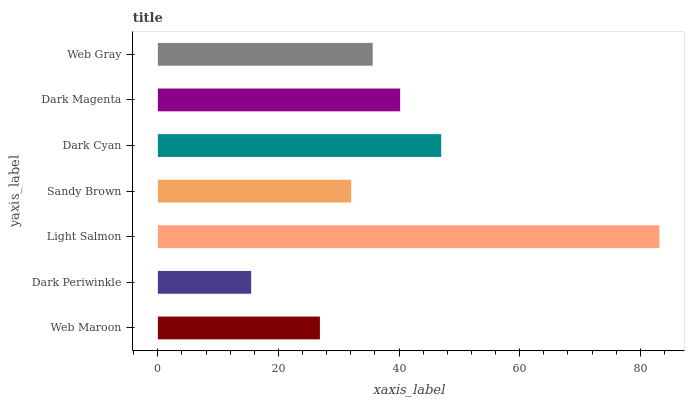Is Dark Periwinkle the minimum?
Answer yes or no. Yes. Is Light Salmon the maximum?
Answer yes or no. Yes. Is Light Salmon the minimum?
Answer yes or no. No. Is Dark Periwinkle the maximum?
Answer yes or no. No. Is Light Salmon greater than Dark Periwinkle?
Answer yes or no. Yes. Is Dark Periwinkle less than Light Salmon?
Answer yes or no. Yes. Is Dark Periwinkle greater than Light Salmon?
Answer yes or no. No. Is Light Salmon less than Dark Periwinkle?
Answer yes or no. No. Is Web Gray the high median?
Answer yes or no. Yes. Is Web Gray the low median?
Answer yes or no. Yes. Is Sandy Brown the high median?
Answer yes or no. No. Is Light Salmon the low median?
Answer yes or no. No. 